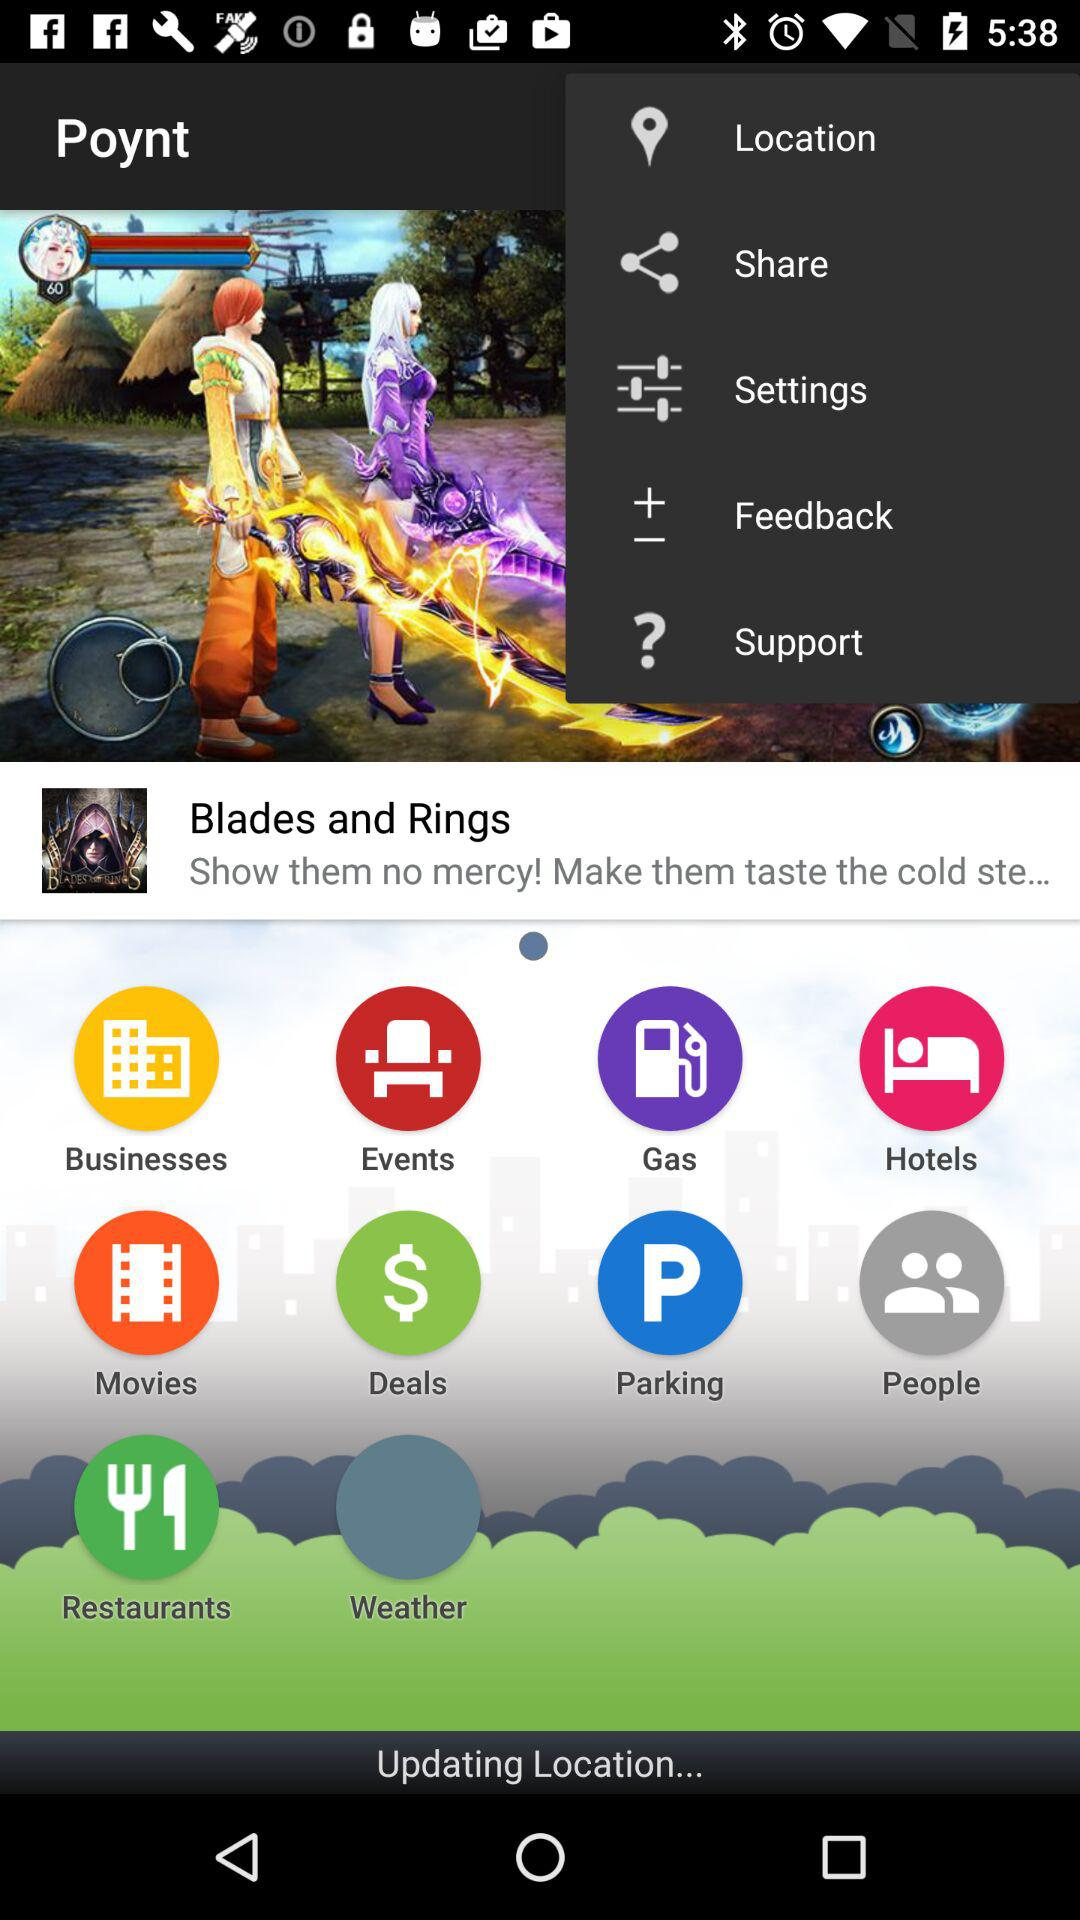What is the name of the game? The name of the game is "Blades and Rings". 